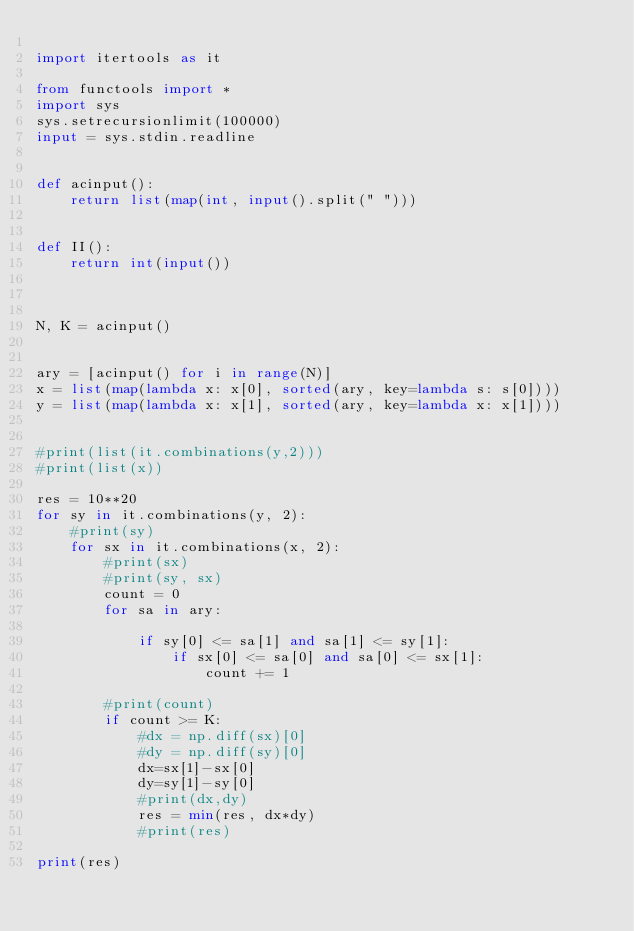<code> <loc_0><loc_0><loc_500><loc_500><_Python_>
import itertools as it

from functools import *
import sys
sys.setrecursionlimit(100000)
input = sys.stdin.readline


def acinput():
    return list(map(int, input().split(" ")))


def II():
    return int(input())



N, K = acinput()


ary = [acinput() for i in range(N)]
x = list(map(lambda x: x[0], sorted(ary, key=lambda s: s[0])))
y = list(map(lambda x: x[1], sorted(ary, key=lambda x: x[1])))


#print(list(it.combinations(y,2)))
#print(list(x))

res = 10**20
for sy in it.combinations(y, 2):
    #print(sy)
    for sx in it.combinations(x, 2):
        #print(sx)
        #print(sy, sx)
        count = 0
        for sa in ary:
            
            if sy[0] <= sa[1] and sa[1] <= sy[1]:
                if sx[0] <= sa[0] and sa[0] <= sx[1]:
                    count += 1

        #print(count)
        if count >= K:
            #dx = np.diff(sx)[0]
            #dy = np.diff(sy)[0]
            dx=sx[1]-sx[0]
            dy=sy[1]-sy[0]
            #print(dx,dy)
            res = min(res, dx*dy)
            #print(res)

print(res)

</code> 